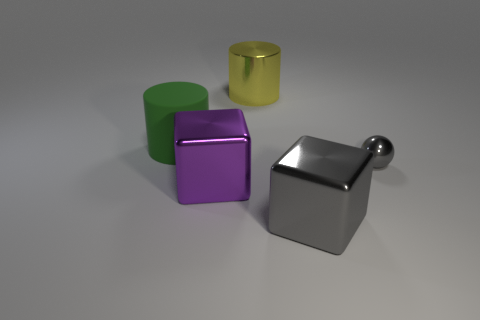Add 3 small cylinders. How many objects exist? 8 Subtract all blocks. How many objects are left? 3 Add 1 metallic cubes. How many metallic cubes exist? 3 Subtract 1 gray balls. How many objects are left? 4 Subtract all metal cylinders. Subtract all matte cylinders. How many objects are left? 3 Add 5 yellow things. How many yellow things are left? 6 